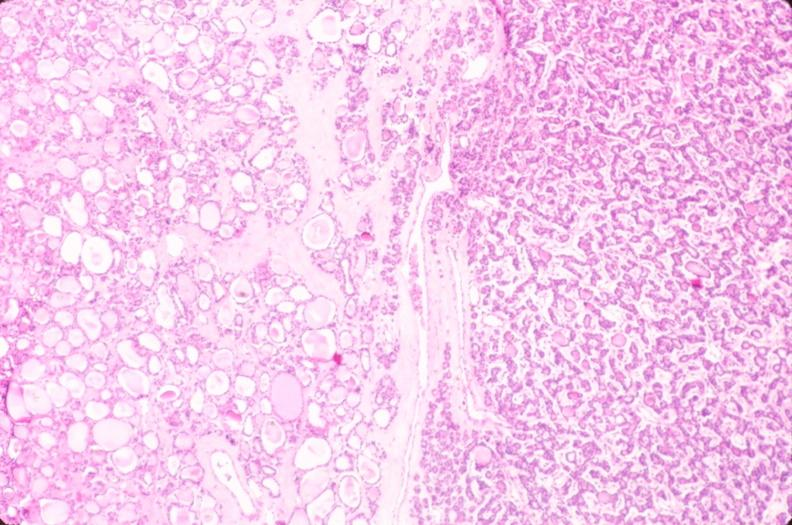s endocrine present?
Answer the question using a single word or phrase. Yes 